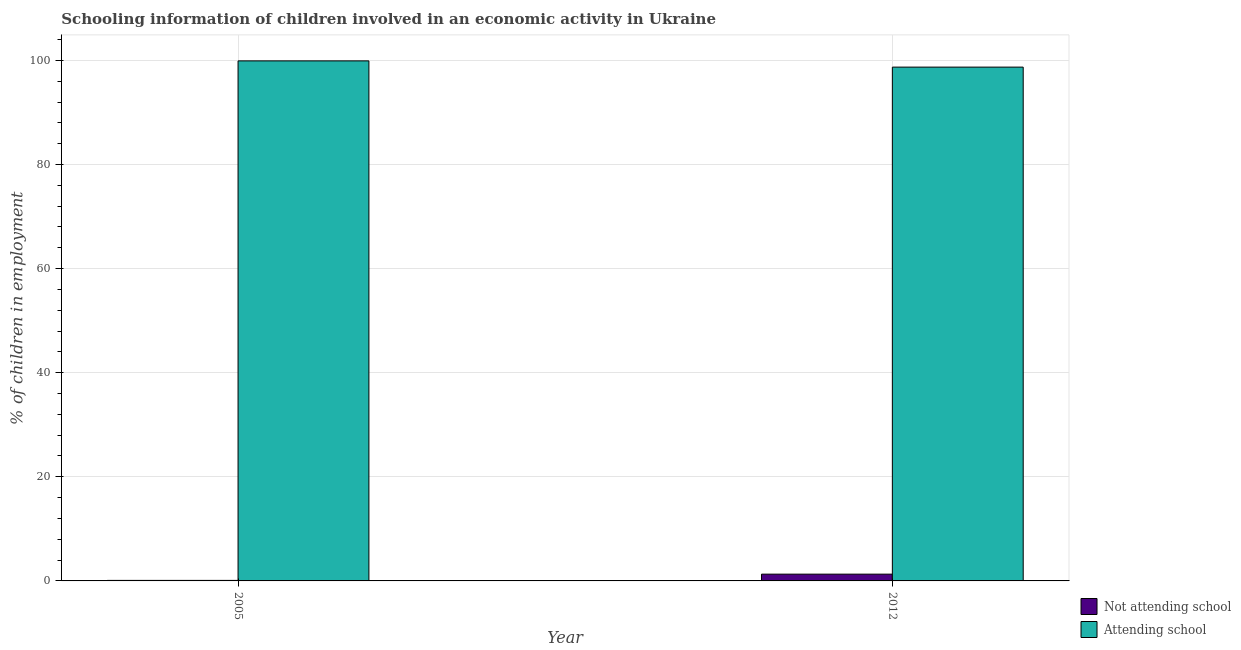How many different coloured bars are there?
Keep it short and to the point. 2. How many groups of bars are there?
Your response must be concise. 2. Are the number of bars on each tick of the X-axis equal?
Your response must be concise. Yes. How many bars are there on the 2nd tick from the right?
Give a very brief answer. 2. What is the percentage of employed children who are not attending school in 2005?
Keep it short and to the point. 0.1. Across all years, what is the maximum percentage of employed children who are attending school?
Ensure brevity in your answer.  99.9. Across all years, what is the minimum percentage of employed children who are attending school?
Offer a terse response. 98.7. In which year was the percentage of employed children who are not attending school maximum?
Make the answer very short. 2012. What is the total percentage of employed children who are attending school in the graph?
Your answer should be compact. 198.6. What is the difference between the percentage of employed children who are not attending school in 2005 and that in 2012?
Provide a succinct answer. -1.2. What is the average percentage of employed children who are not attending school per year?
Offer a very short reply. 0.7. In how many years, is the percentage of employed children who are not attending school greater than 88 %?
Ensure brevity in your answer.  0. What is the ratio of the percentage of employed children who are not attending school in 2005 to that in 2012?
Your answer should be compact. 0.08. Is the percentage of employed children who are not attending school in 2005 less than that in 2012?
Provide a short and direct response. Yes. In how many years, is the percentage of employed children who are not attending school greater than the average percentage of employed children who are not attending school taken over all years?
Give a very brief answer. 1. What does the 2nd bar from the left in 2005 represents?
Your answer should be compact. Attending school. What does the 1st bar from the right in 2012 represents?
Your answer should be very brief. Attending school. How many bars are there?
Provide a succinct answer. 4. Where does the legend appear in the graph?
Provide a succinct answer. Bottom right. How many legend labels are there?
Provide a short and direct response. 2. How are the legend labels stacked?
Offer a very short reply. Vertical. What is the title of the graph?
Offer a very short reply. Schooling information of children involved in an economic activity in Ukraine. Does "Register a property" appear as one of the legend labels in the graph?
Provide a succinct answer. No. What is the label or title of the X-axis?
Your response must be concise. Year. What is the label or title of the Y-axis?
Your answer should be compact. % of children in employment. What is the % of children in employment of Not attending school in 2005?
Your response must be concise. 0.1. What is the % of children in employment in Attending school in 2005?
Ensure brevity in your answer.  99.9. What is the % of children in employment in Attending school in 2012?
Give a very brief answer. 98.7. Across all years, what is the maximum % of children in employment in Not attending school?
Provide a succinct answer. 1.3. Across all years, what is the maximum % of children in employment of Attending school?
Offer a terse response. 99.9. Across all years, what is the minimum % of children in employment in Attending school?
Keep it short and to the point. 98.7. What is the total % of children in employment in Not attending school in the graph?
Your answer should be compact. 1.4. What is the total % of children in employment in Attending school in the graph?
Make the answer very short. 198.6. What is the difference between the % of children in employment of Attending school in 2005 and that in 2012?
Your response must be concise. 1.2. What is the difference between the % of children in employment in Not attending school in 2005 and the % of children in employment in Attending school in 2012?
Your response must be concise. -98.6. What is the average % of children in employment in Attending school per year?
Make the answer very short. 99.3. In the year 2005, what is the difference between the % of children in employment of Not attending school and % of children in employment of Attending school?
Your answer should be very brief. -99.8. In the year 2012, what is the difference between the % of children in employment of Not attending school and % of children in employment of Attending school?
Your response must be concise. -97.4. What is the ratio of the % of children in employment of Not attending school in 2005 to that in 2012?
Provide a short and direct response. 0.08. What is the ratio of the % of children in employment in Attending school in 2005 to that in 2012?
Offer a terse response. 1.01. What is the difference between the highest and the second highest % of children in employment in Not attending school?
Ensure brevity in your answer.  1.2. What is the difference between the highest and the second highest % of children in employment in Attending school?
Offer a very short reply. 1.2. What is the difference between the highest and the lowest % of children in employment in Not attending school?
Give a very brief answer. 1.2. What is the difference between the highest and the lowest % of children in employment of Attending school?
Your answer should be compact. 1.2. 